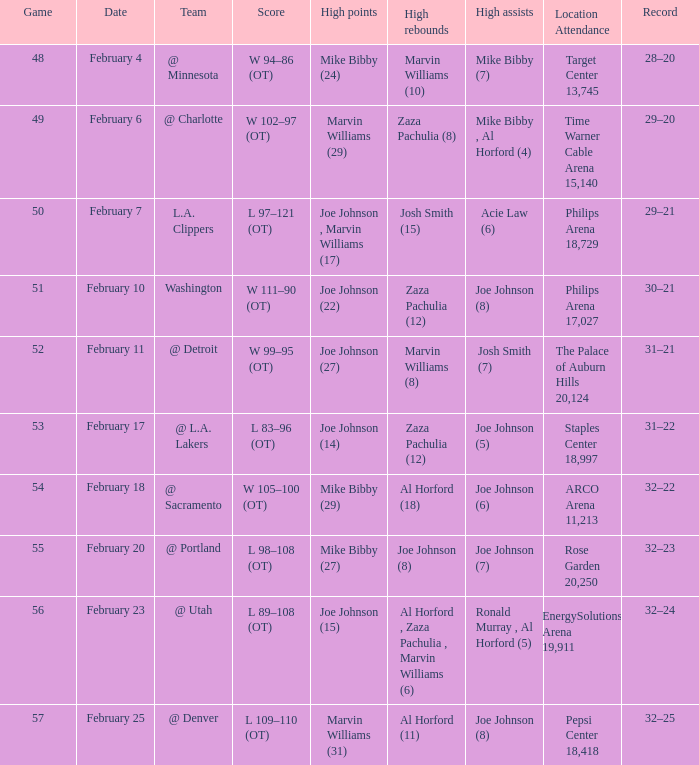Could you parse the entire table as a dict? {'header': ['Game', 'Date', 'Team', 'Score', 'High points', 'High rebounds', 'High assists', 'Location Attendance', 'Record'], 'rows': [['48', 'February 4', '@ Minnesota', 'W 94–86 (OT)', 'Mike Bibby (24)', 'Marvin Williams (10)', 'Mike Bibby (7)', 'Target Center 13,745', '28–20'], ['49', 'February 6', '@ Charlotte', 'W 102–97 (OT)', 'Marvin Williams (29)', 'Zaza Pachulia (8)', 'Mike Bibby , Al Horford (4)', 'Time Warner Cable Arena 15,140', '29–20'], ['50', 'February 7', 'L.A. Clippers', 'L 97–121 (OT)', 'Joe Johnson , Marvin Williams (17)', 'Josh Smith (15)', 'Acie Law (6)', 'Philips Arena 18,729', '29–21'], ['51', 'February 10', 'Washington', 'W 111–90 (OT)', 'Joe Johnson (22)', 'Zaza Pachulia (12)', 'Joe Johnson (8)', 'Philips Arena 17,027', '30–21'], ['52', 'February 11', '@ Detroit', 'W 99–95 (OT)', 'Joe Johnson (27)', 'Marvin Williams (8)', 'Josh Smith (7)', 'The Palace of Auburn Hills 20,124', '31–21'], ['53', 'February 17', '@ L.A. Lakers', 'L 83–96 (OT)', 'Joe Johnson (14)', 'Zaza Pachulia (12)', 'Joe Johnson (5)', 'Staples Center 18,997', '31–22'], ['54', 'February 18', '@ Sacramento', 'W 105–100 (OT)', 'Mike Bibby (29)', 'Al Horford (18)', 'Joe Johnson (6)', 'ARCO Arena 11,213', '32–22'], ['55', 'February 20', '@ Portland', 'L 98–108 (OT)', 'Mike Bibby (27)', 'Joe Johnson (8)', 'Joe Johnson (7)', 'Rose Garden 20,250', '32–23'], ['56', 'February 23', '@ Utah', 'L 89–108 (OT)', 'Joe Johnson (15)', 'Al Horford , Zaza Pachulia , Marvin Williams (6)', 'Ronald Murray , Al Horford (5)', 'EnergySolutions Arena 19,911', '32–24'], ['57', 'February 25', '@ Denver', 'L 109–110 (OT)', 'Marvin Williams (31)', 'Al Horford (11)', 'Joe Johnson (8)', 'Pepsi Center 18,418', '32–25']]} On february 4, who had the highest number of assists? Mike Bibby (7). 